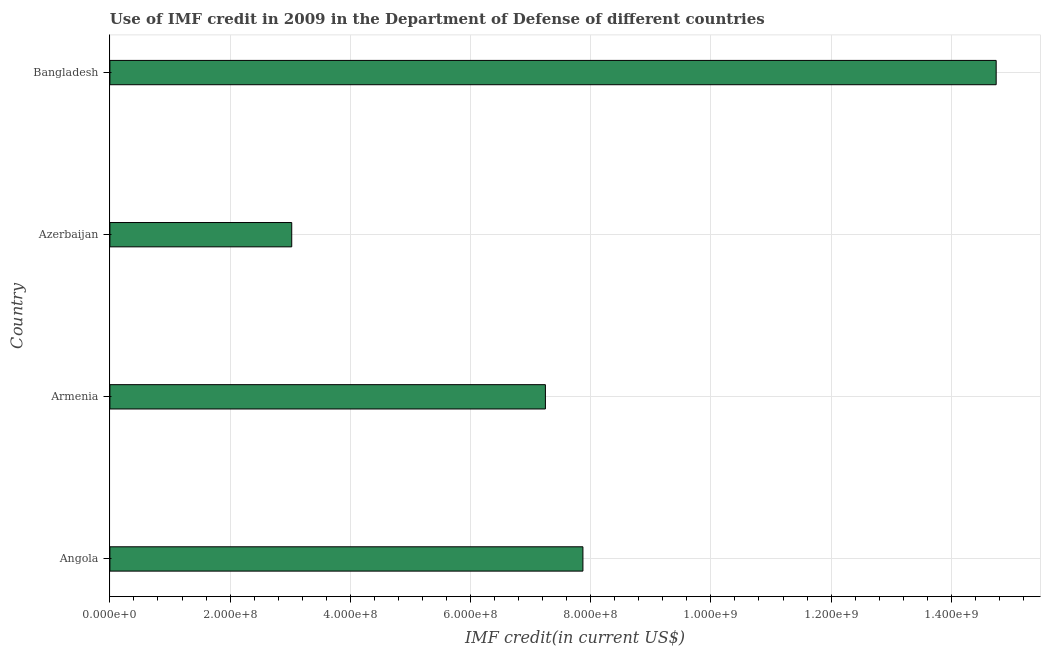Does the graph contain any zero values?
Provide a short and direct response. No. What is the title of the graph?
Your response must be concise. Use of IMF credit in 2009 in the Department of Defense of different countries. What is the label or title of the X-axis?
Your answer should be compact. IMF credit(in current US$). What is the use of imf credit in dod in Armenia?
Give a very brief answer. 7.25e+08. Across all countries, what is the maximum use of imf credit in dod?
Keep it short and to the point. 1.47e+09. Across all countries, what is the minimum use of imf credit in dod?
Keep it short and to the point. 3.03e+08. In which country was the use of imf credit in dod maximum?
Provide a succinct answer. Bangladesh. In which country was the use of imf credit in dod minimum?
Your response must be concise. Azerbaijan. What is the sum of the use of imf credit in dod?
Offer a very short reply. 3.29e+09. What is the difference between the use of imf credit in dod in Armenia and Bangladesh?
Keep it short and to the point. -7.50e+08. What is the average use of imf credit in dod per country?
Give a very brief answer. 8.22e+08. What is the median use of imf credit in dod?
Your answer should be compact. 7.56e+08. In how many countries, is the use of imf credit in dod greater than 1080000000 US$?
Offer a very short reply. 1. What is the ratio of the use of imf credit in dod in Angola to that in Armenia?
Give a very brief answer. 1.09. What is the difference between the highest and the second highest use of imf credit in dod?
Offer a very short reply. 6.88e+08. What is the difference between the highest and the lowest use of imf credit in dod?
Keep it short and to the point. 1.17e+09. Are all the bars in the graph horizontal?
Provide a short and direct response. Yes. How many countries are there in the graph?
Your answer should be compact. 4. What is the difference between two consecutive major ticks on the X-axis?
Your response must be concise. 2.00e+08. Are the values on the major ticks of X-axis written in scientific E-notation?
Give a very brief answer. Yes. What is the IMF credit(in current US$) of Angola?
Your answer should be compact. 7.87e+08. What is the IMF credit(in current US$) in Armenia?
Provide a short and direct response. 7.25e+08. What is the IMF credit(in current US$) of Azerbaijan?
Make the answer very short. 3.03e+08. What is the IMF credit(in current US$) of Bangladesh?
Your answer should be compact. 1.47e+09. What is the difference between the IMF credit(in current US$) in Angola and Armenia?
Keep it short and to the point. 6.24e+07. What is the difference between the IMF credit(in current US$) in Angola and Azerbaijan?
Your response must be concise. 4.84e+08. What is the difference between the IMF credit(in current US$) in Angola and Bangladesh?
Your answer should be very brief. -6.88e+08. What is the difference between the IMF credit(in current US$) in Armenia and Azerbaijan?
Your answer should be very brief. 4.22e+08. What is the difference between the IMF credit(in current US$) in Armenia and Bangladesh?
Your response must be concise. -7.50e+08. What is the difference between the IMF credit(in current US$) in Azerbaijan and Bangladesh?
Offer a terse response. -1.17e+09. What is the ratio of the IMF credit(in current US$) in Angola to that in Armenia?
Your answer should be compact. 1.09. What is the ratio of the IMF credit(in current US$) in Angola to that in Azerbaijan?
Keep it short and to the point. 2.6. What is the ratio of the IMF credit(in current US$) in Angola to that in Bangladesh?
Make the answer very short. 0.53. What is the ratio of the IMF credit(in current US$) in Armenia to that in Azerbaijan?
Your answer should be compact. 2.4. What is the ratio of the IMF credit(in current US$) in Armenia to that in Bangladesh?
Your answer should be very brief. 0.49. What is the ratio of the IMF credit(in current US$) in Azerbaijan to that in Bangladesh?
Give a very brief answer. 0.2. 